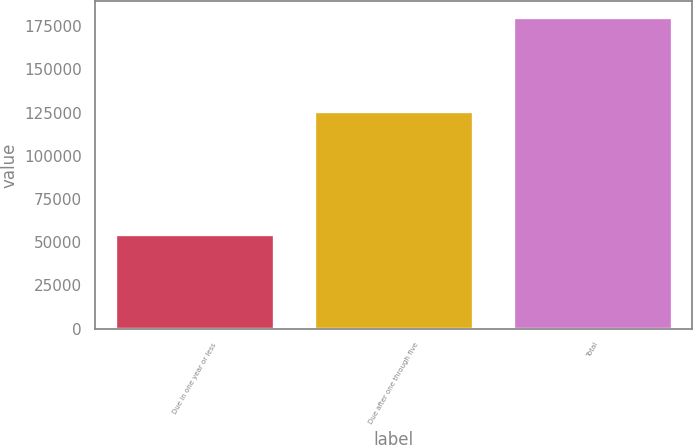<chart> <loc_0><loc_0><loc_500><loc_500><bar_chart><fcel>Due in one year or less<fcel>Due after one through five<fcel>Total<nl><fcel>54543<fcel>125775<fcel>180318<nl></chart> 